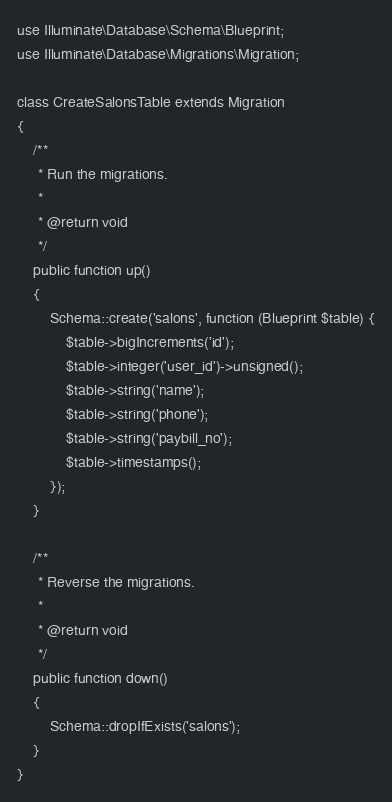<code> <loc_0><loc_0><loc_500><loc_500><_PHP_>use Illuminate\Database\Schema\Blueprint;
use Illuminate\Database\Migrations\Migration;

class CreateSalonsTable extends Migration
{
    /**
     * Run the migrations.
     *
     * @return void
     */
    public function up()
    {
        Schema::create('salons', function (Blueprint $table) {
            $table->bigIncrements('id');
            $table->integer('user_id')->unsigned();
            $table->string('name');
            $table->string('phone');
            $table->string('paybill_no');
            $table->timestamps();
        });
    }

    /**
     * Reverse the migrations.
     *
     * @return void
     */
    public function down()
    {
        Schema::dropIfExists('salons');
    }
}
</code> 